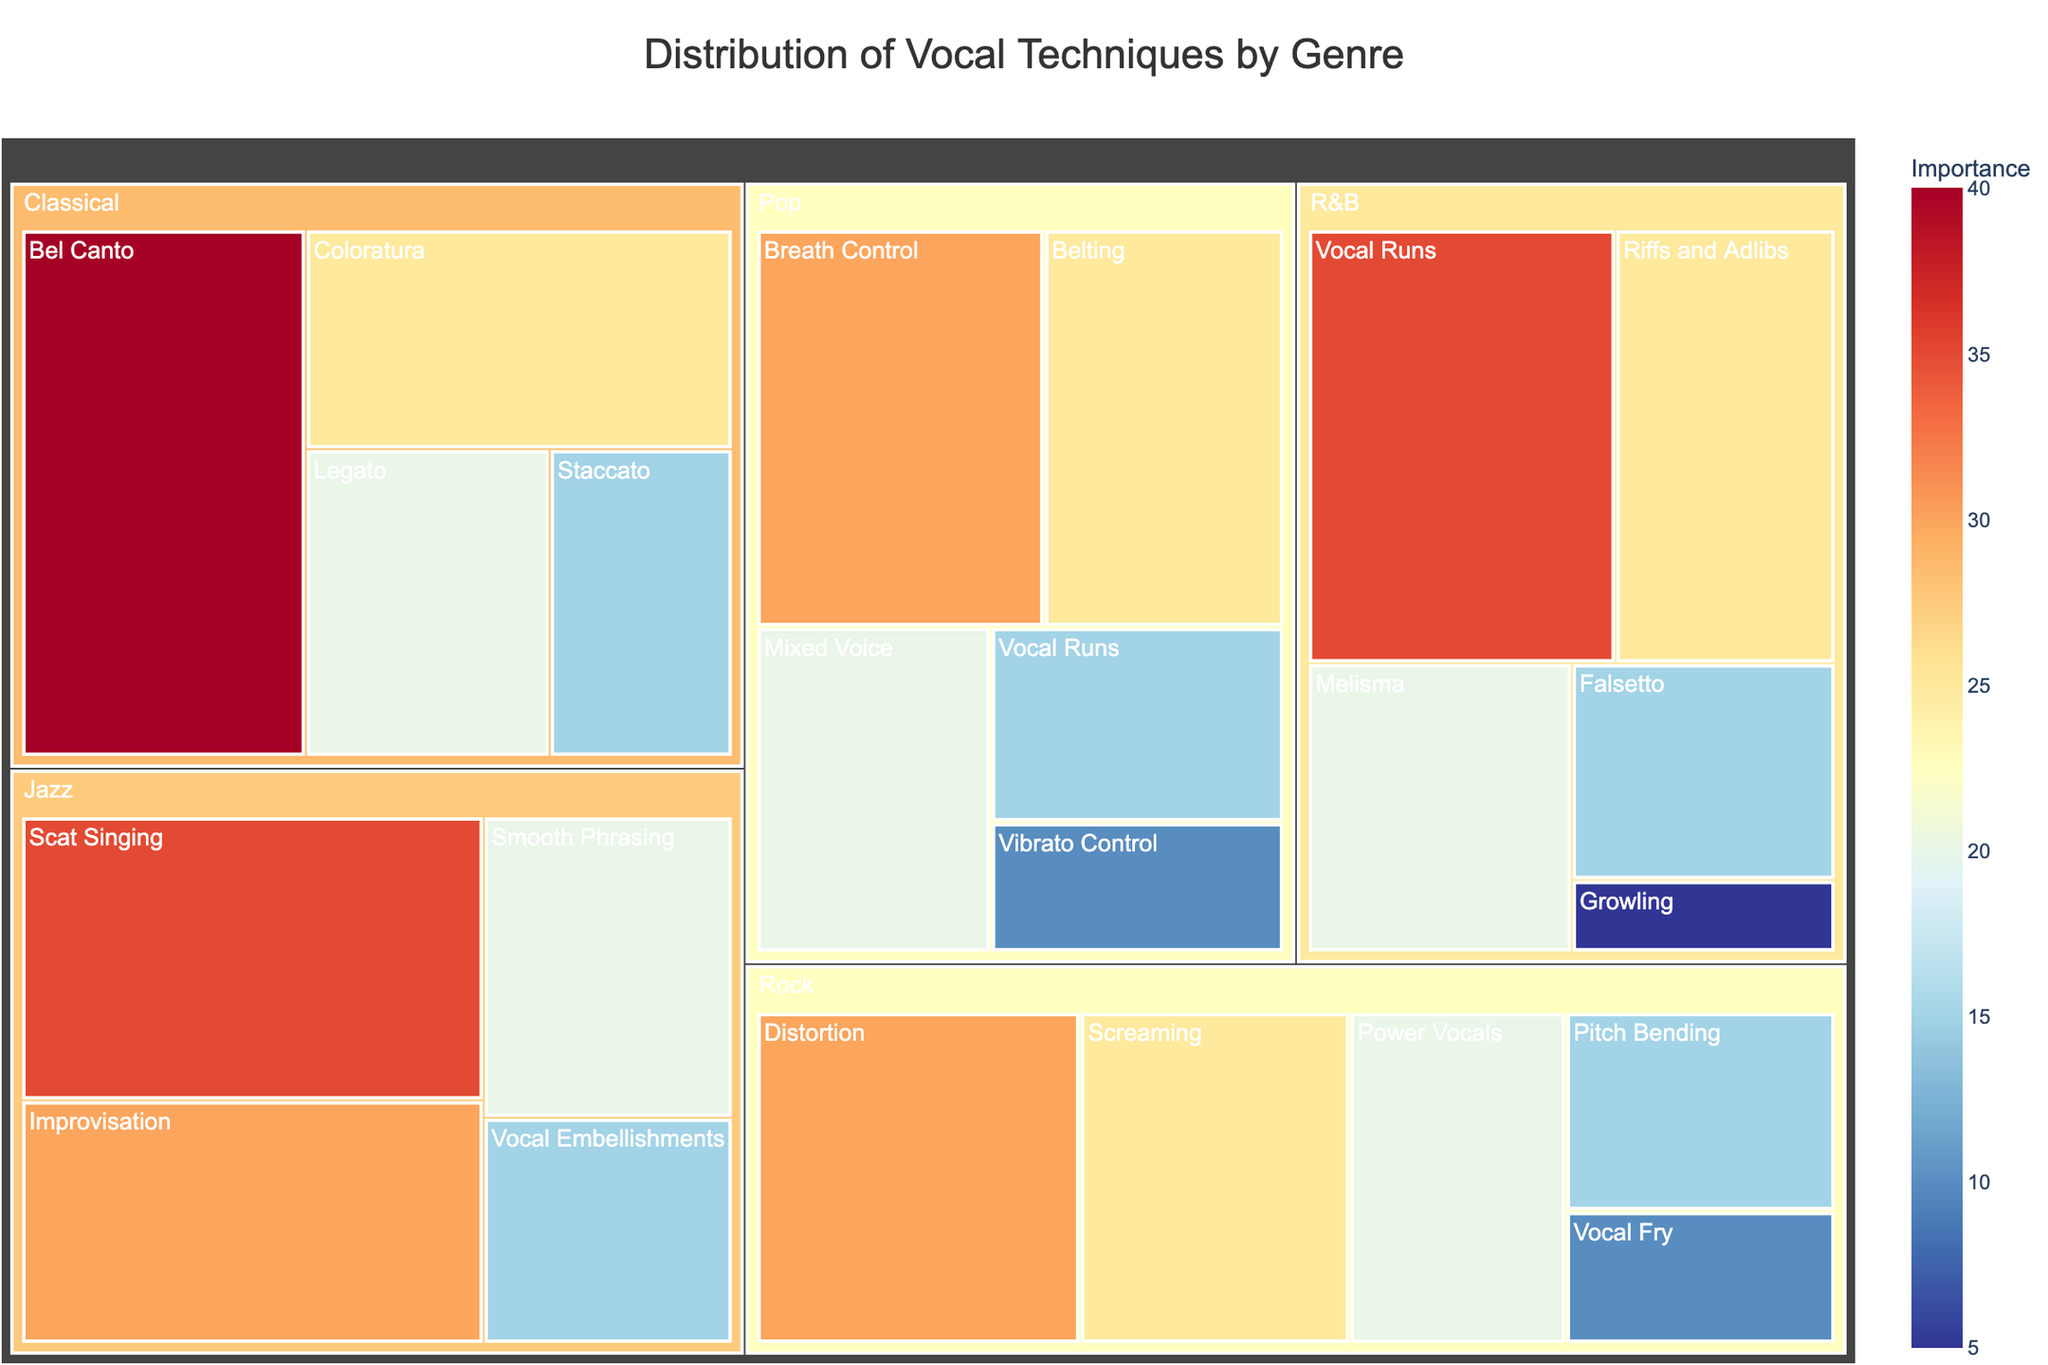What is the title of the figure? The title is usually placed at the top of the figure and provides a summary of what the figure is about. By reading the title, one can quickly understand the general subject of the figure.
Answer: Distribution of Vocal Techniques by Genre What vocal technique in Pop is taught the most? The figure shows the size of each segment proportional to its value, with the largest segment in Pop representing the most taught vocal technique.
Answer: Breath Control Which genre has the highest value for any single vocal technique? By comparing all the segments across different genres, we can see the segments with the highest values and identify the genre they belong to. Classical has a segment with a value of 40.
Answer: Classical How many vocal techniques are represented in the Jazz genre? By counting the number of segments within the Jazz category in the treemap, one can determine the number of vocal techniques represented in Jazz.
Answer: 4 Compare the importance of Screaming in Rock and Vibrato Control in Pop. Which is higher? The figure shows different segments by their size and value. By comparing the given values, Screaming in Rock is 25 while Vibrato Control in Pop is 10.
Answer: Screaming in Rock What's the total value of vocal techniques taught in Rock? By adding up the values of all segments within the Rock genre, we get the total value. The values are 30 (Distortion) + 25 (Screaming) + 20 (Power Vocals) + 15 (Pitch Bending) + 10 (Vocal Fry), which sums up to 100.
Answer: 100 Which genre focuses more on vocal runs, Pop or R&B? Compare the values for Vocal Runs in both genres. In Pop, Vocal Runs have a value of 15, while in R&B, they have a value of 35.
Answer: R&B What is the smallest value for any vocal technique in the figure? By identifying the smallest segment across all genres, we can determine the vocal technique with the smallest value. Growling in R&B has a value of 5.
Answer: 5 Are there any genres where a single vocal technique constitutes more than 30% of the genre's total? Calculate the total value for each genre and compare individual technique values to see if they exceed 30% of the total value for that genre. For Classical, Bel Canto has a value of 40; the total for Classical is 100, making Bel Canto 40% of the genre's total.
Answer: Yes What is the average value of vocal techniques taught in Classical? Sum the values of all vocal techniques in Classical and then divide by the number of techniques. Values are 40 (Bel Canto) + 25 (Coloratura) + 20 (Legato) + 15 (Staccato) = 100. Average is 100/4 = 25.
Answer: 25 